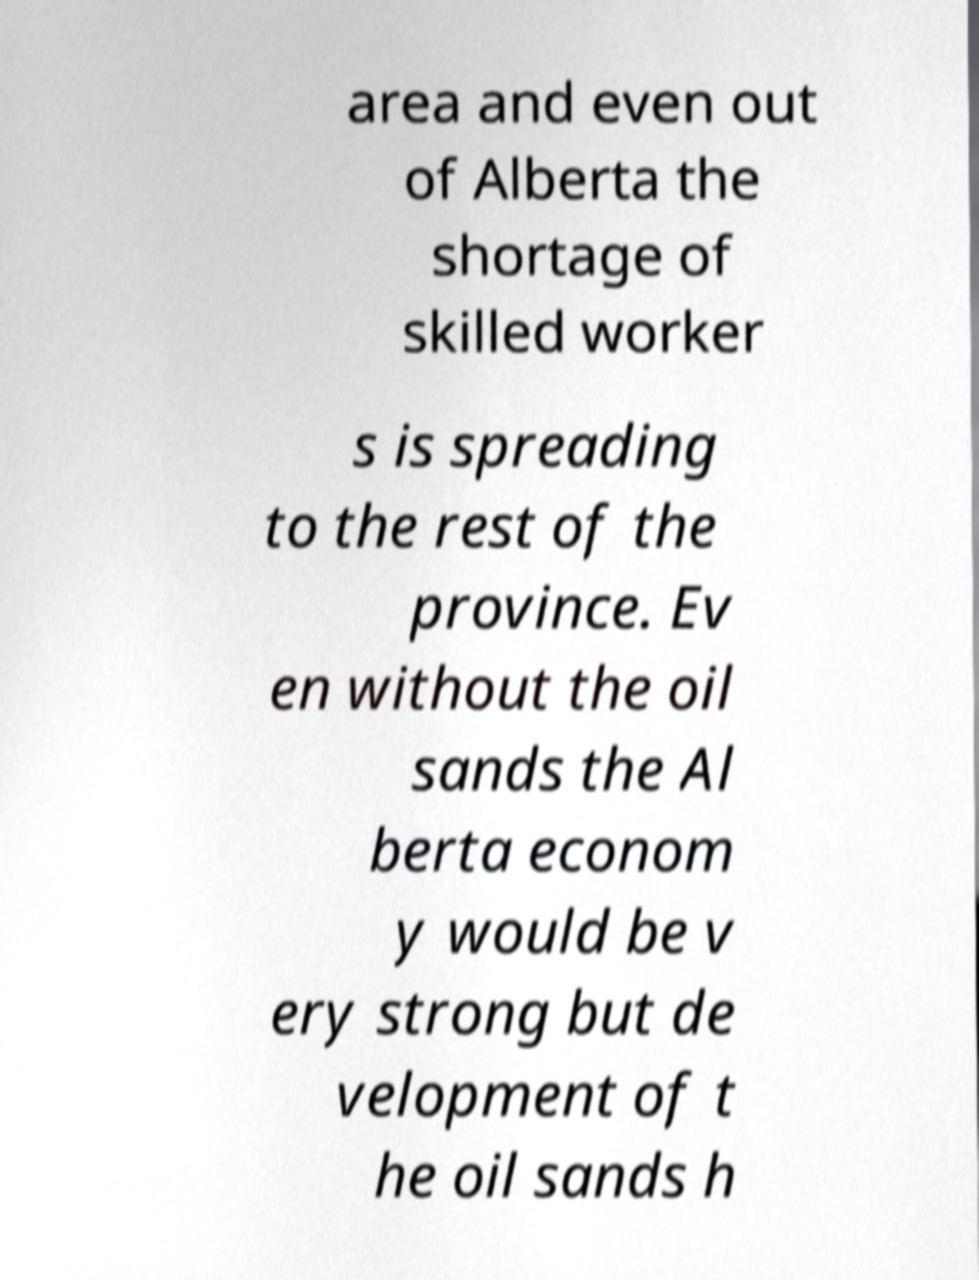Could you extract and type out the text from this image? area and even out of Alberta the shortage of skilled worker s is spreading to the rest of the province. Ev en without the oil sands the Al berta econom y would be v ery strong but de velopment of t he oil sands h 